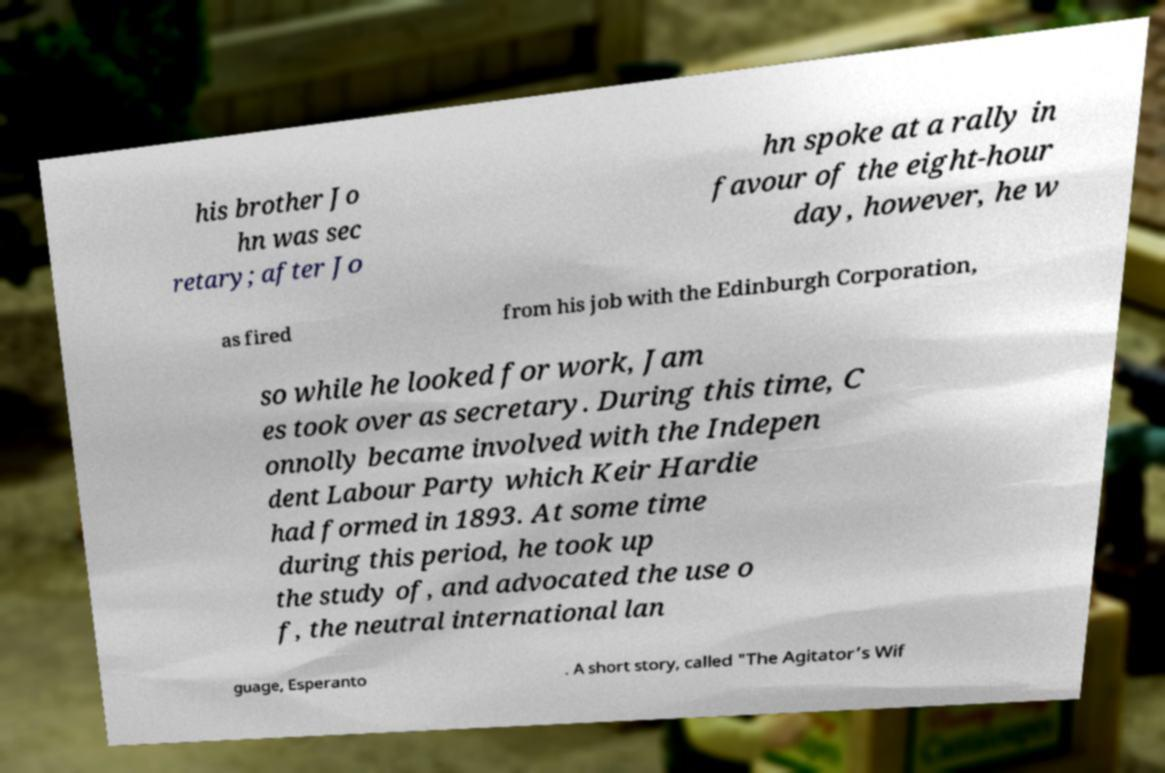Can you accurately transcribe the text from the provided image for me? his brother Jo hn was sec retary; after Jo hn spoke at a rally in favour of the eight-hour day, however, he w as fired from his job with the Edinburgh Corporation, so while he looked for work, Jam es took over as secretary. During this time, C onnolly became involved with the Indepen dent Labour Party which Keir Hardie had formed in 1893. At some time during this period, he took up the study of, and advocated the use o f, the neutral international lan guage, Esperanto . A short story, called "The Agitator’s Wif 